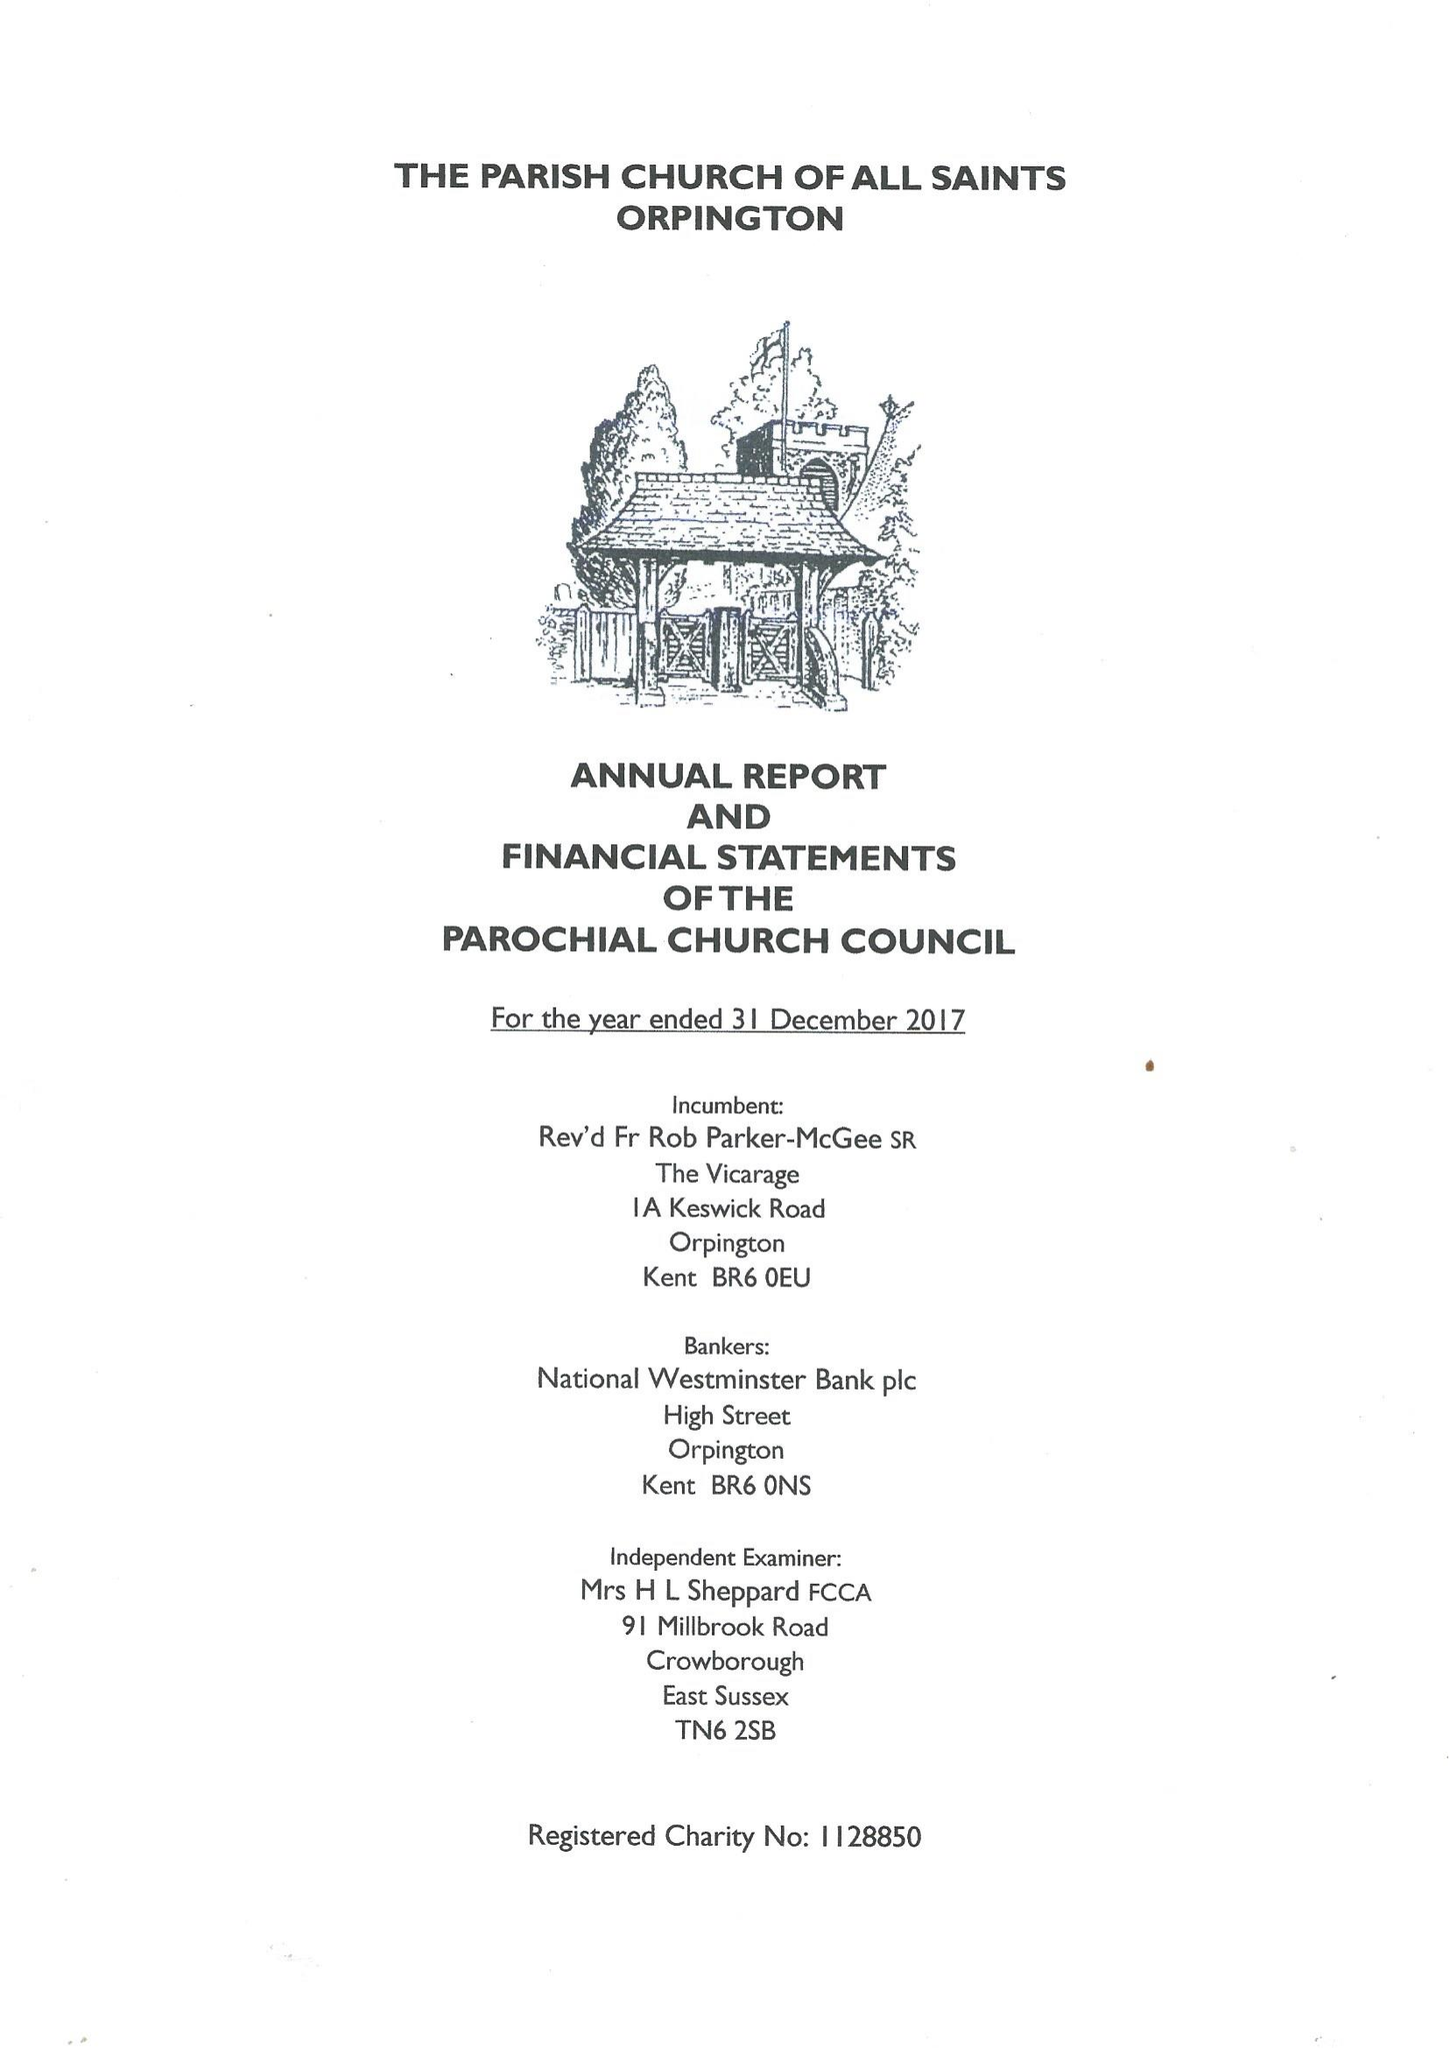What is the value for the charity_name?
Answer the question using a single word or phrase. The Parochial Church Council Of The Ecclesiastical Parish Of Orpington 